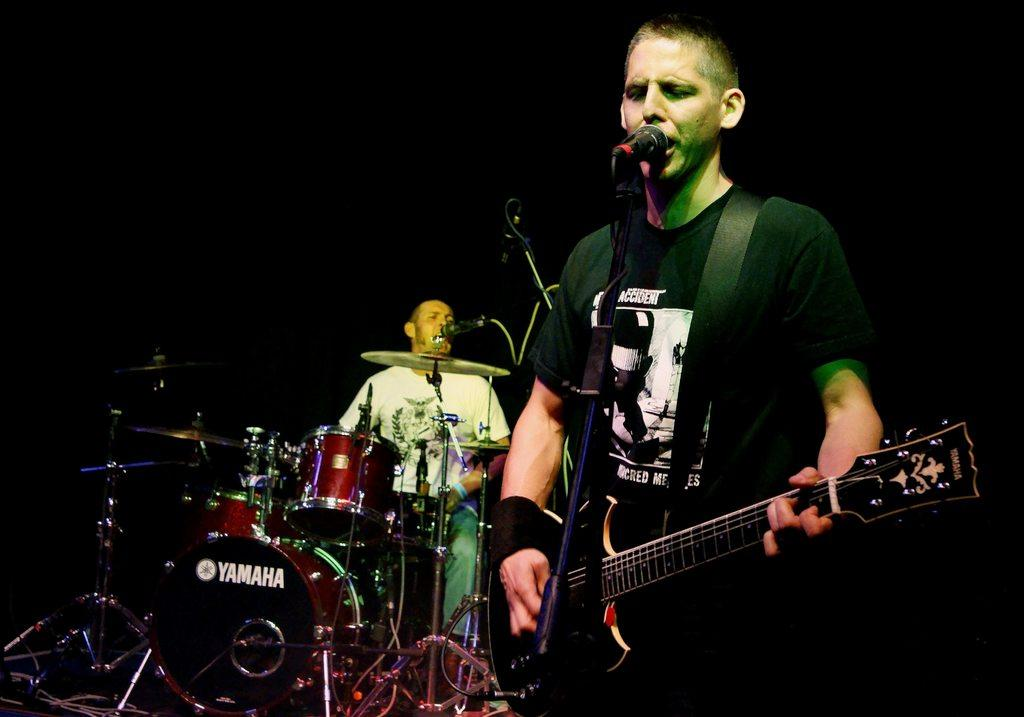What is the man in the image doing? The man is playing the drums. Are there any other musicians in the image? Yes, there is a man singing in the image. How is the man singing using a microphone? The man singing is using a microphone to amplify his voice. What other instrument is the man singing playing? The man singing is also playing the guitar. What type of poison is the man using to enhance his guitar playing in the image? There is no poison present in the image, and the man is not using any substance to enhance his guitar playing. 